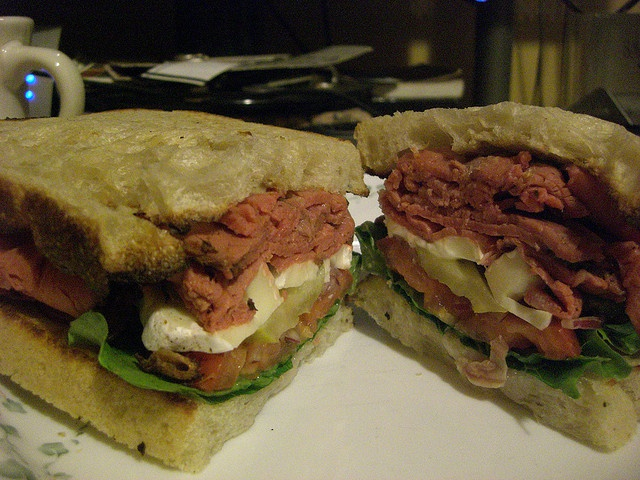Describe the objects in this image and their specific colors. I can see sandwich in black and olive tones, sandwich in black, olive, maroon, and gray tones, and cup in black, olive, and gray tones in this image. 